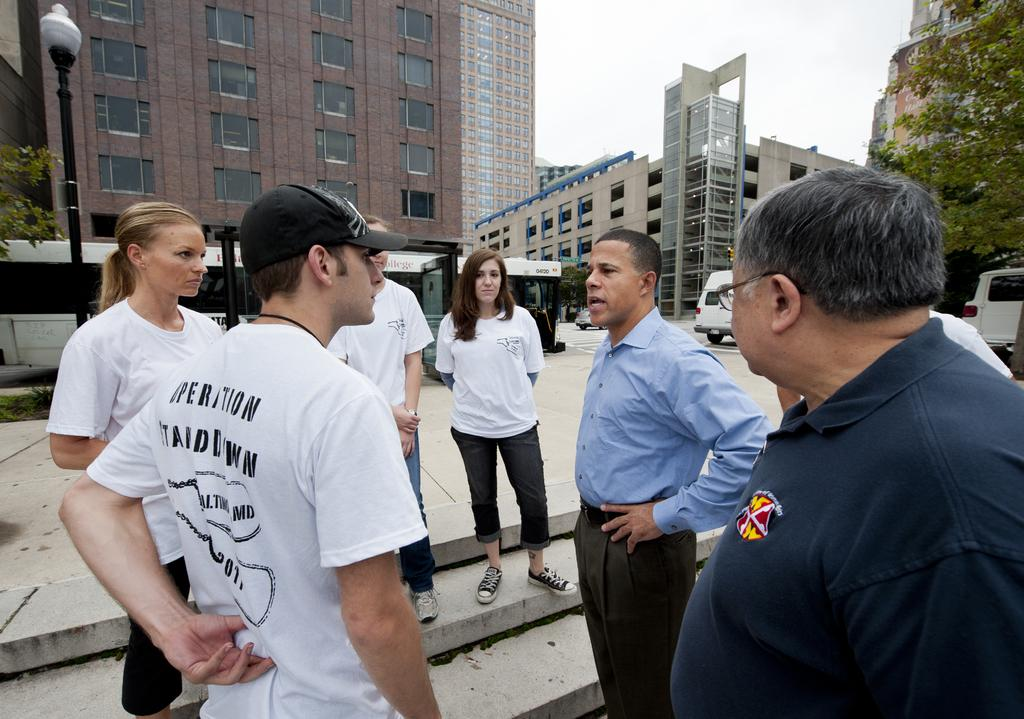What is the main subject of the image? The main subject of the image is a group of men standing in the center. Where are the men standing? The men are standing on the ground. What can be seen in the background of the image? There are buildings, a street light, trees, vehicles, a road, and the sky visible in the background. What type of berry is being used as a hat by one of the men in the image? There are no berries present in the image, and none of the men are wearing berries as hats. 